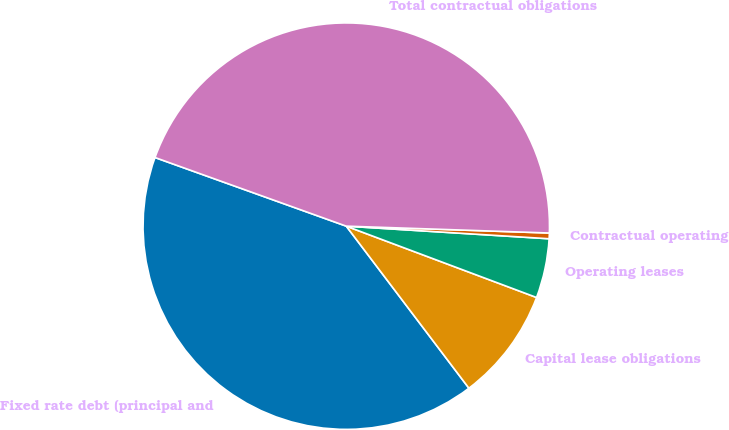Convert chart. <chart><loc_0><loc_0><loc_500><loc_500><pie_chart><fcel>Fixed rate debt (principal and<fcel>Capital lease obligations<fcel>Operating leases<fcel>Contractual operating<fcel>Total contractual obligations<nl><fcel>40.79%<fcel>8.98%<fcel>4.72%<fcel>0.45%<fcel>45.05%<nl></chart> 